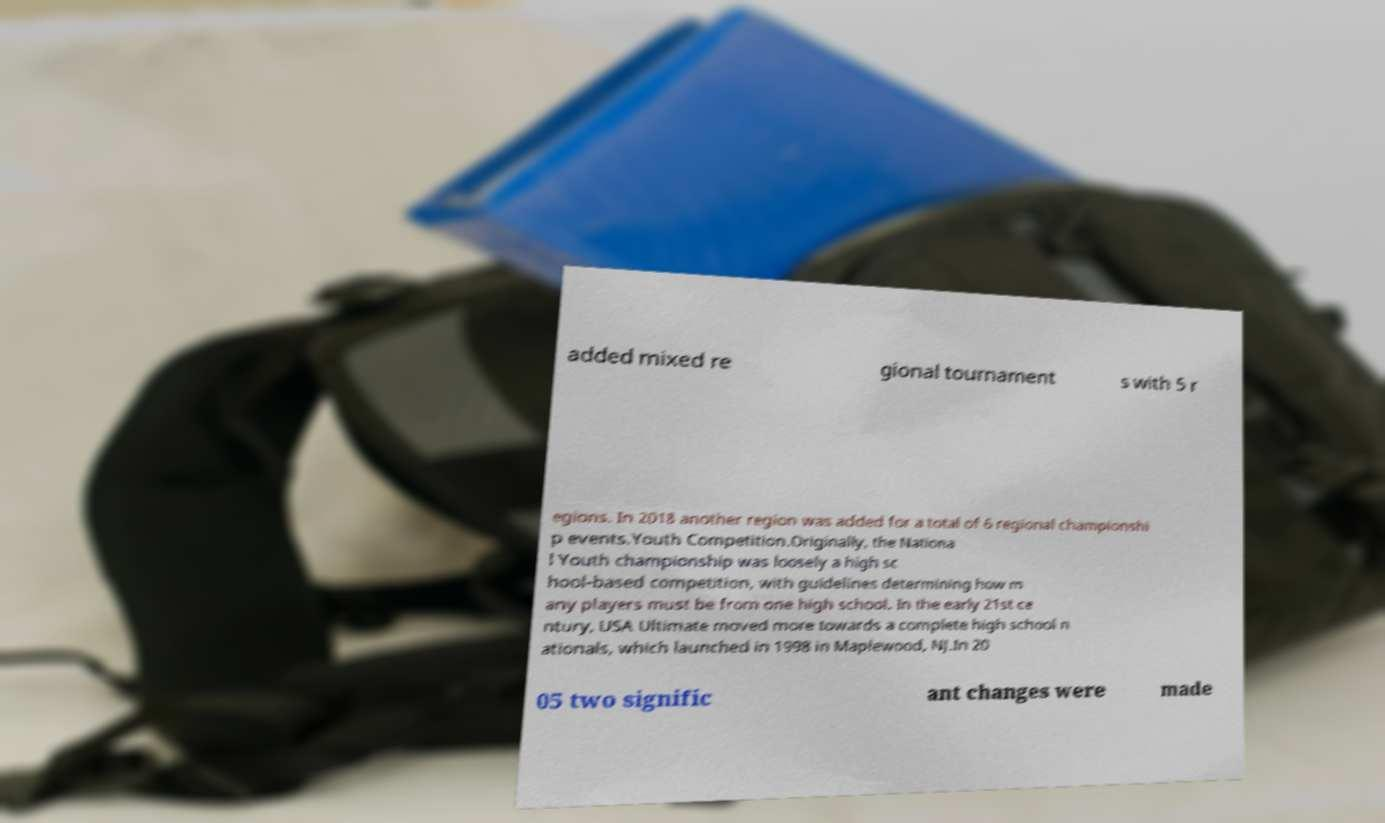Can you accurately transcribe the text from the provided image for me? added mixed re gional tournament s with 5 r egions. In 2018 another region was added for a total of 6 regional championshi p events.Youth Competition.Originally, the Nationa l Youth championship was loosely a high sc hool-based competition, with guidelines determining how m any players must be from one high school. In the early 21st ce ntury, USA Ultimate moved more towards a complete high school n ationals, which launched in 1998 in Maplewood, NJ.In 20 05 two signific ant changes were made 